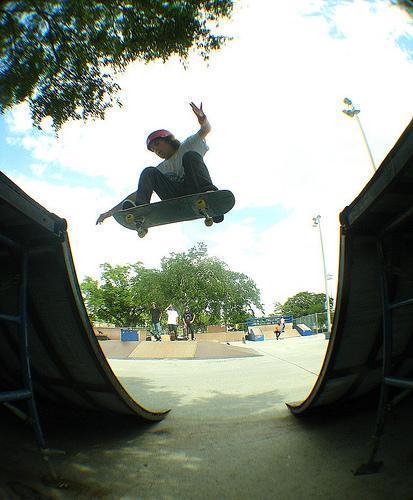How many people are in the picture?
Give a very brief answer. 1. 